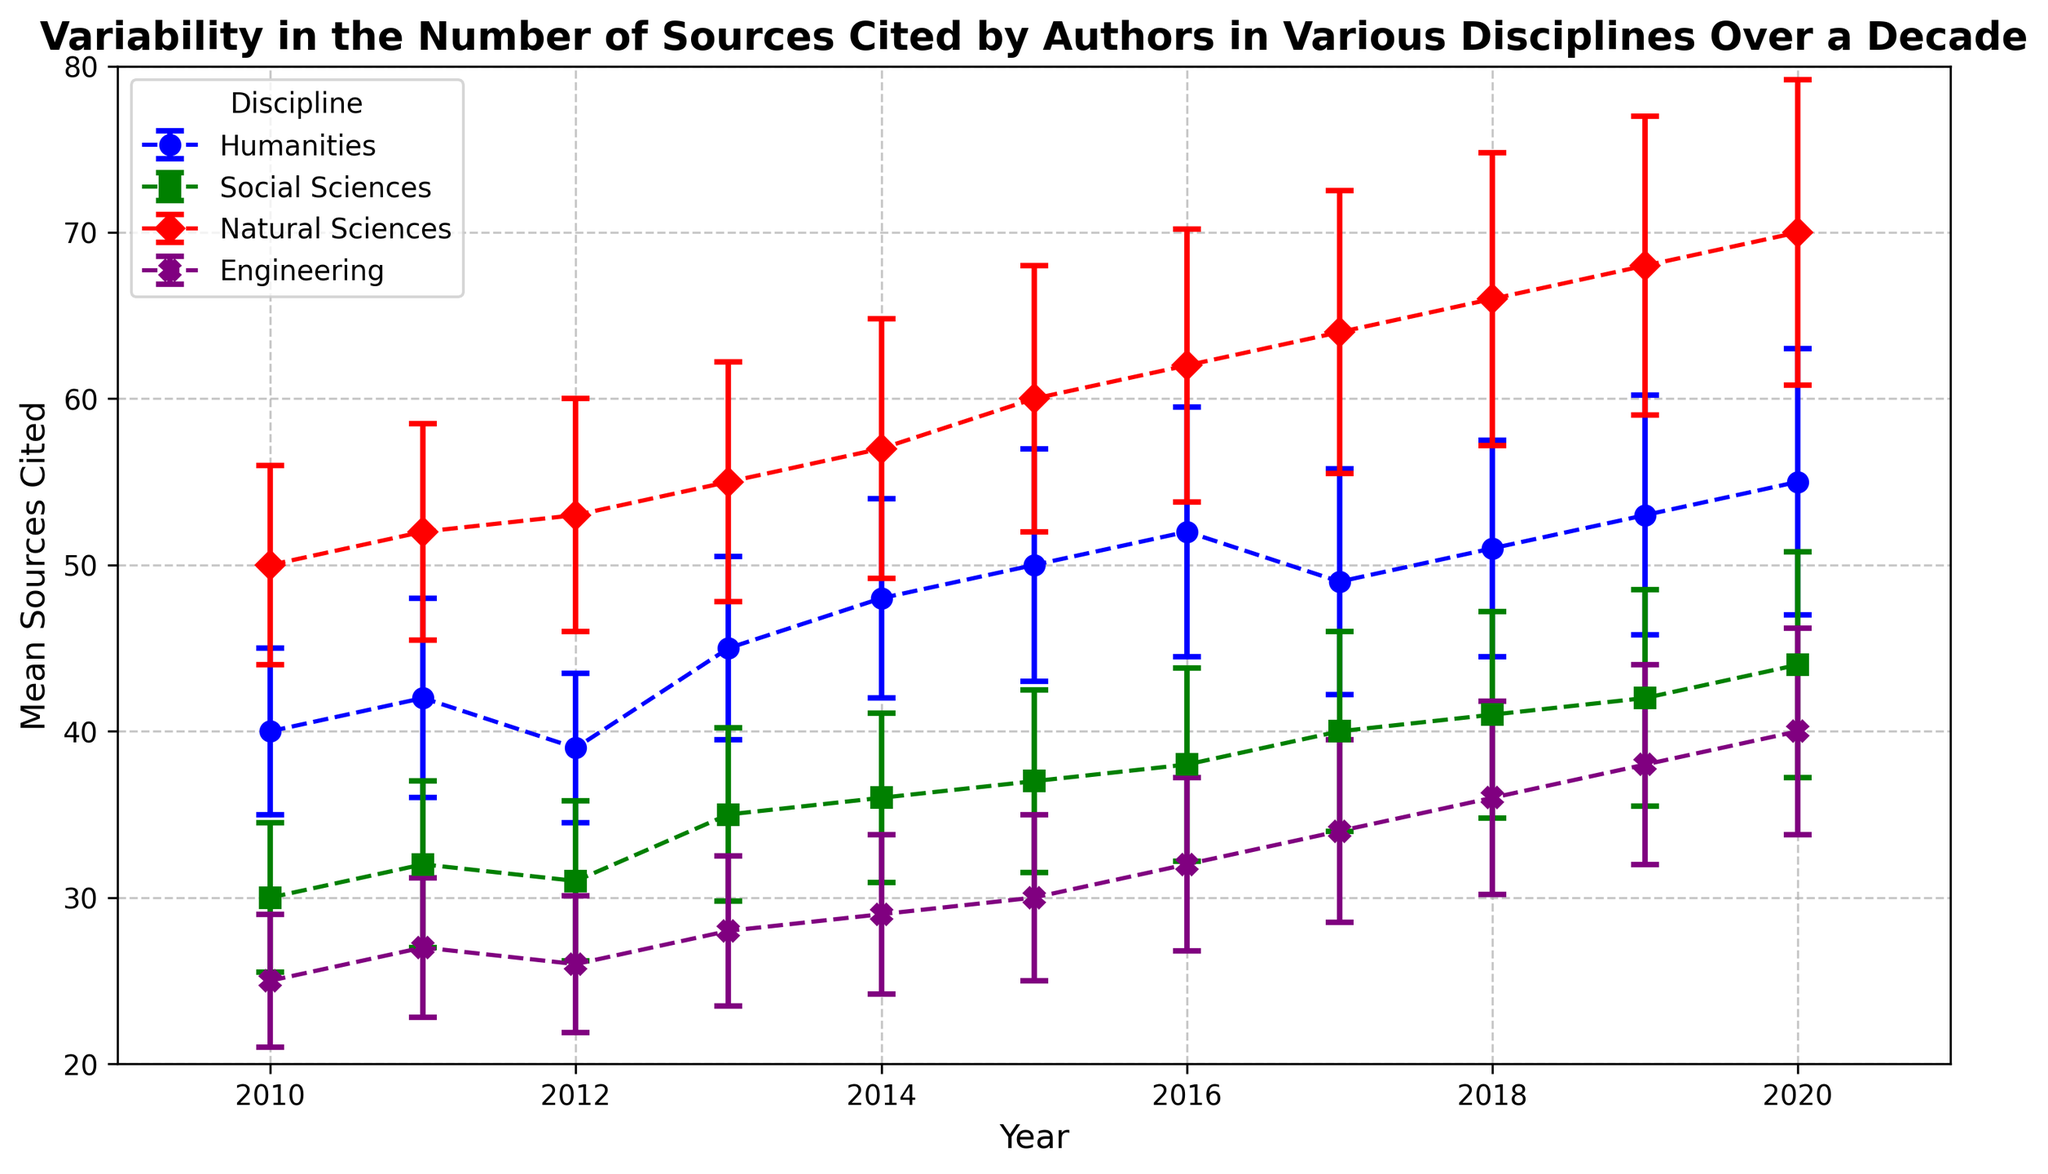What's the trend in the mean number of sources cited in the Humanities discipline over the decade? The Humanities discipline shows an increasing trend, with the mean number of sources cited rising from 40 in 2010 to 55 in 2020.
Answer: Increasing Which discipline had the highest mean number of sources cited in 2020? By examining the mean value at the year 2020 on the plot, the Natural Sciences discipline had the highest mean number of sources cited, which was 70.
Answer: Natural Sciences Compare the variability of sources cited between Social Sciences and Engineering in 2015. Which one exhibits more variability? To compare variability, we look at the error bars representing standard deviation. For Social Sciences in 2015, the standard deviation is 5.5, while for Engineering in 2015, it is 5.0. Therefore, Social Sciences exhibit more variability.
Answer: Social Sciences What is the overall trend in the Natural Sciences discipline? The overall trend in the Natural Sciences discipline is an upward trend, with the mean number of sources cited increasing from 50 in 2010 to 70 in 2020.
Answer: Upward How does the mean number of sources cited in Engineering in 2019 compare to that in 2012? By comparing the mean values for Engineering in 2019 and 2012, we see that the mean increased from 26 in 2012 to 38 in 2019.
Answer: Increased In what year did the Social Sciences discipline first reach a mean of 40 sources cited? By examining the mean values for the Social Sciences discipline over the decade, the year they first reached a mean of 40 sources cited was 2017.
Answer: 2017 Which discipline shows the least variability in their mean number of sources cited over the decade? By analyzing the length of the error bars for all disciplines across all years, the Engineering discipline exhibits the least variability, with the standard deviation values generally lower compared to other disciplines.
Answer: Engineering Calculate the average mean number of sources cited for the Humanities discipline over the decade. Summing the means for the Humanities from 2010 to 2020 and dividing by the number of years: (40 + 42 + 39 + 45 + 48 + 50 + 52 + 49 + 51 + 53 + 55) / 11 = 474 / 11 ≈ 43.09
Answer: ≈ 43.09 Compare the increase in the mean number of sources cited from 2010 to 2020 for Humanities and Natural Sciences. Which discipline shows a greater increase? Humanities increased from 40 to 55, an increase of 15 sources. Natural Sciences increased from 50 to 70, an increase of 20 sources. Therefore, Natural Sciences shows a greater increase.
Answer: Natural Sciences Identify the discipline with the highest variability in 2020. By examining the error bars for the year 2020, the Natural Sciences discipline shows the highest variability with a standard deviation of 9.2.
Answer: Natural Sciences 